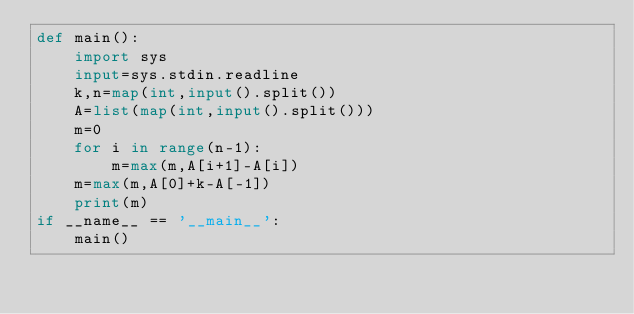Convert code to text. <code><loc_0><loc_0><loc_500><loc_500><_Python_>def main():
    import sys
    input=sys.stdin.readline
    k,n=map(int,input().split())
    A=list(map(int,input().split()))
    m=0
    for i in range(n-1):
        m=max(m,A[i+1]-A[i])
    m=max(m,A[0]+k-A[-1])
    print(m)
if __name__ == '__main__':
    main()</code> 